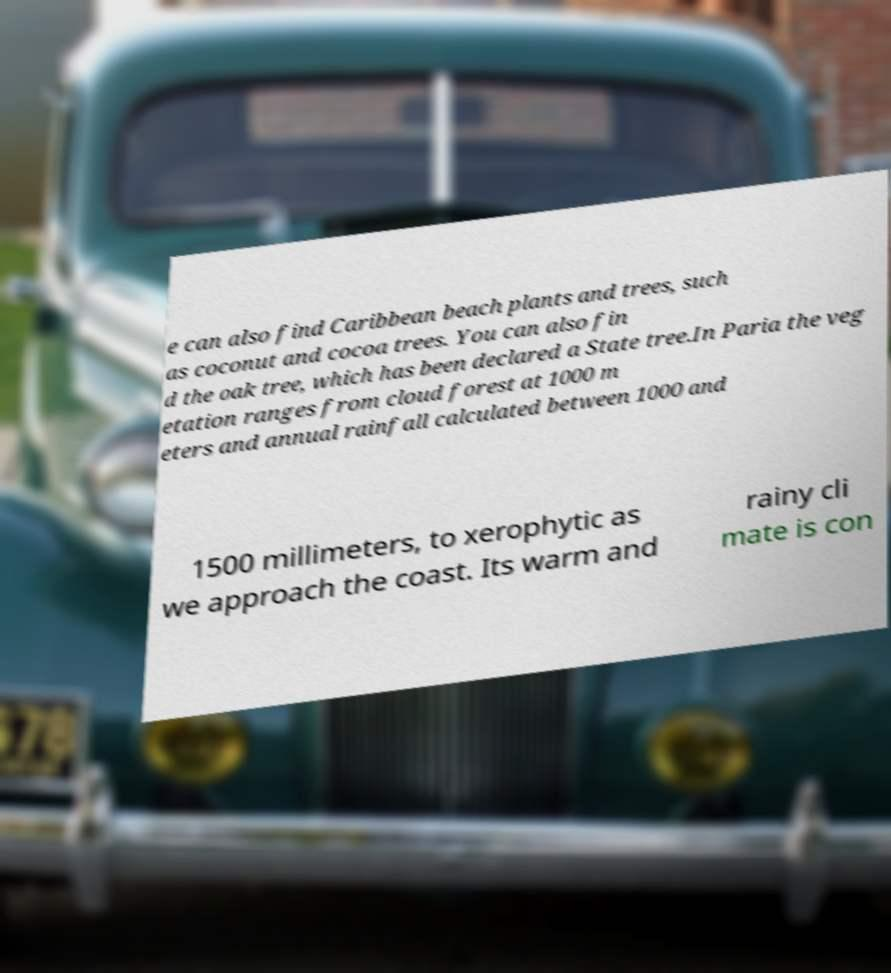Could you assist in decoding the text presented in this image and type it out clearly? e can also find Caribbean beach plants and trees, such as coconut and cocoa trees. You can also fin d the oak tree, which has been declared a State tree.In Paria the veg etation ranges from cloud forest at 1000 m eters and annual rainfall calculated between 1000 and 1500 millimeters, to xerophytic as we approach the coast. Its warm and rainy cli mate is con 